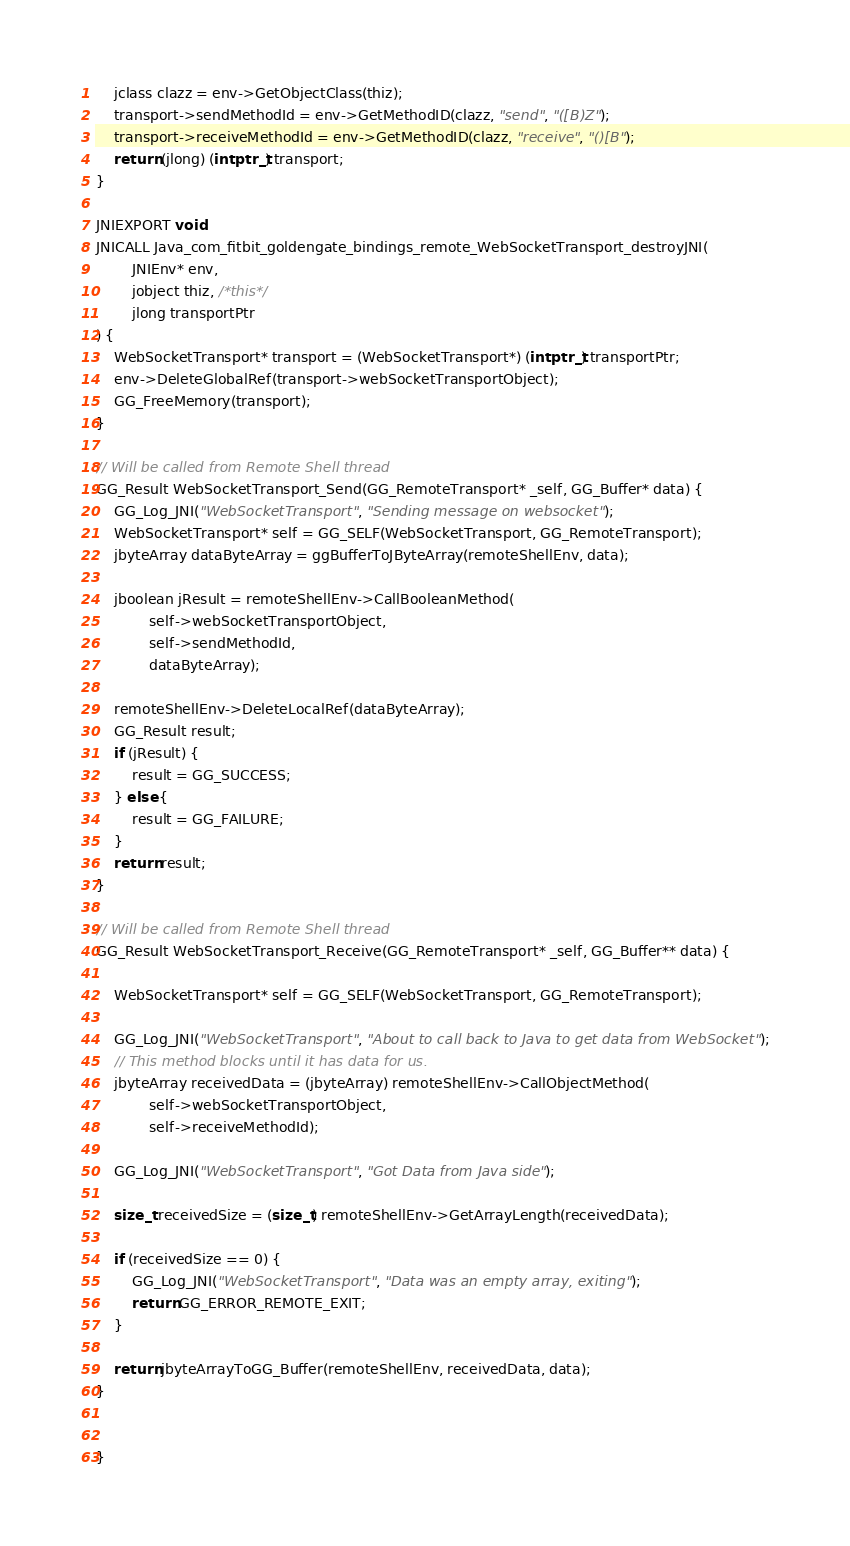Convert code to text. <code><loc_0><loc_0><loc_500><loc_500><_C++_>    jclass clazz = env->GetObjectClass(thiz);
    transport->sendMethodId = env->GetMethodID(clazz, "send", "([B)Z");
    transport->receiveMethodId = env->GetMethodID(clazz, "receive", "()[B");
    return (jlong) (intptr_t) transport;
}

JNIEXPORT void
JNICALL Java_com_fitbit_goldengate_bindings_remote_WebSocketTransport_destroyJNI(
        JNIEnv* env,
        jobject thiz, /*this*/
        jlong transportPtr
) {
    WebSocketTransport* transport = (WebSocketTransport*) (intptr_t) transportPtr;
    env->DeleteGlobalRef(transport->webSocketTransportObject);
    GG_FreeMemory(transport);
}

// Will be called from Remote Shell thread
GG_Result WebSocketTransport_Send(GG_RemoteTransport* _self, GG_Buffer* data) {
    GG_Log_JNI("WebSocketTransport", "Sending message on websocket");
    WebSocketTransport* self = GG_SELF(WebSocketTransport, GG_RemoteTransport);
    jbyteArray dataByteArray = ggBufferToJByteArray(remoteShellEnv, data);

    jboolean jResult = remoteShellEnv->CallBooleanMethod(
            self->webSocketTransportObject,
            self->sendMethodId,
            dataByteArray);

    remoteShellEnv->DeleteLocalRef(dataByteArray);
    GG_Result result;
    if (jResult) {
        result = GG_SUCCESS;
    } else {
        result = GG_FAILURE;
    }
    return result;
}

// Will be called from Remote Shell thread
GG_Result WebSocketTransport_Receive(GG_RemoteTransport* _self, GG_Buffer** data) {

    WebSocketTransport* self = GG_SELF(WebSocketTransport, GG_RemoteTransport);

    GG_Log_JNI("WebSocketTransport", "About to call back to Java to get data from WebSocket");
    // This method blocks until it has data for us.
    jbyteArray receivedData = (jbyteArray) remoteShellEnv->CallObjectMethod(
            self->webSocketTransportObject,
            self->receiveMethodId);

    GG_Log_JNI("WebSocketTransport", "Got Data from Java side");

    size_t receivedSize = (size_t) remoteShellEnv->GetArrayLength(receivedData);

    if (receivedSize == 0) {
        GG_Log_JNI("WebSocketTransport", "Data was an empty array, exiting");
        return GG_ERROR_REMOTE_EXIT;
    }

    return jbyteArrayToGG_Buffer(remoteShellEnv, receivedData, data);
}


}
</code> 